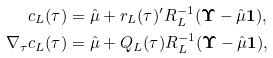Convert formula to latex. <formula><loc_0><loc_0><loc_500><loc_500>c _ { L } ( \tau ) & = \hat { \mu } + r _ { L } ( \tau ) ^ { \prime } R _ { L } ^ { - 1 } ( \mathbf \Upsilon - \hat { \mu } \mathbf 1 ) , \\ \nabla _ { \tau } c _ { L } ( \tau ) & = \hat { \mu } + Q _ { L } ( \tau ) R _ { L } ^ { - 1 } ( \mathbf \Upsilon - \hat { \mu } \mathbf 1 ) ,</formula> 